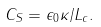Convert formula to latex. <formula><loc_0><loc_0><loc_500><loc_500>C _ { S } = \epsilon _ { 0 } \kappa / L _ { c } .</formula> 